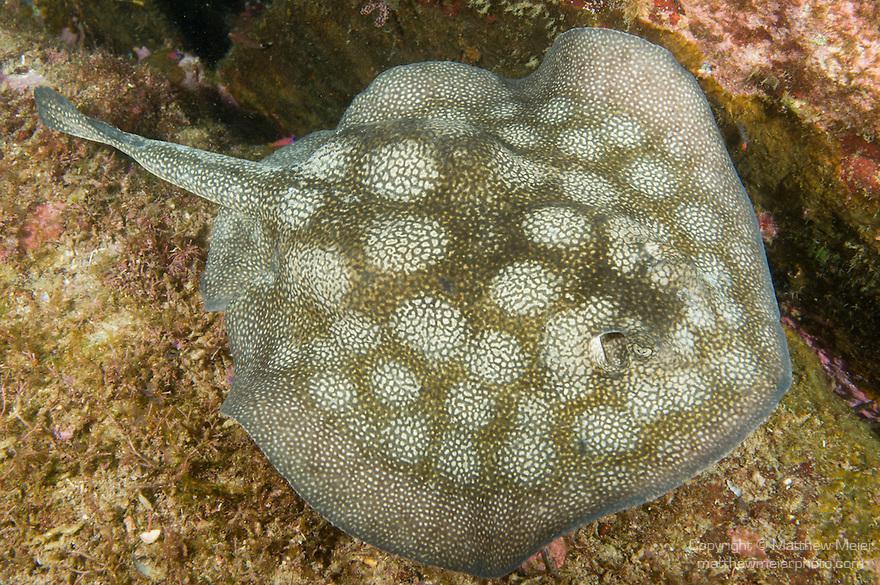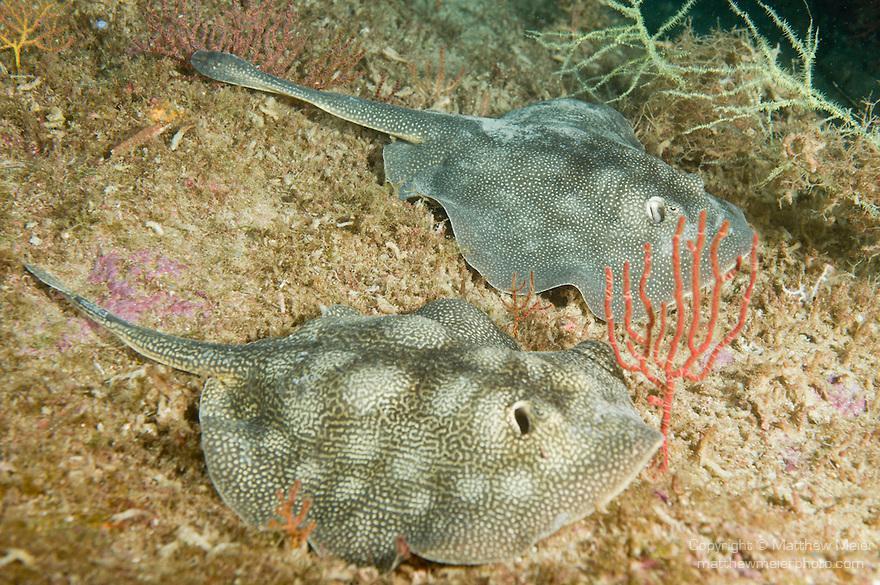The first image is the image on the left, the second image is the image on the right. Considering the images on both sides, is "In at least one image a stingray's spine points to the 10:00 position." valid? Answer yes or no. Yes. 